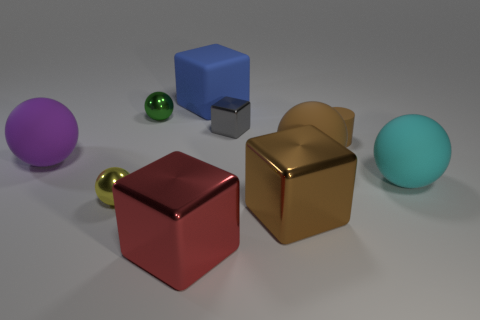Subtract 1 balls. How many balls are left? 4 Subtract all brown balls. How many balls are left? 4 Subtract all red blocks. How many blocks are left? 3 Subtract all gray balls. Subtract all yellow cubes. How many balls are left? 5 Subtract all blocks. How many objects are left? 6 Add 3 large purple matte objects. How many large purple matte objects are left? 4 Add 4 gray objects. How many gray objects exist? 5 Subtract 0 blue balls. How many objects are left? 10 Subtract all rubber blocks. Subtract all brown shiny objects. How many objects are left? 8 